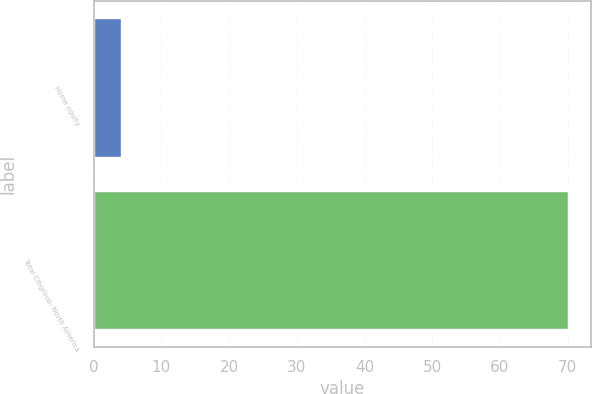Convert chart to OTSL. <chart><loc_0><loc_0><loc_500><loc_500><bar_chart><fcel>Home equity<fcel>Total Citigroup- North America<nl><fcel>4<fcel>70<nl></chart> 